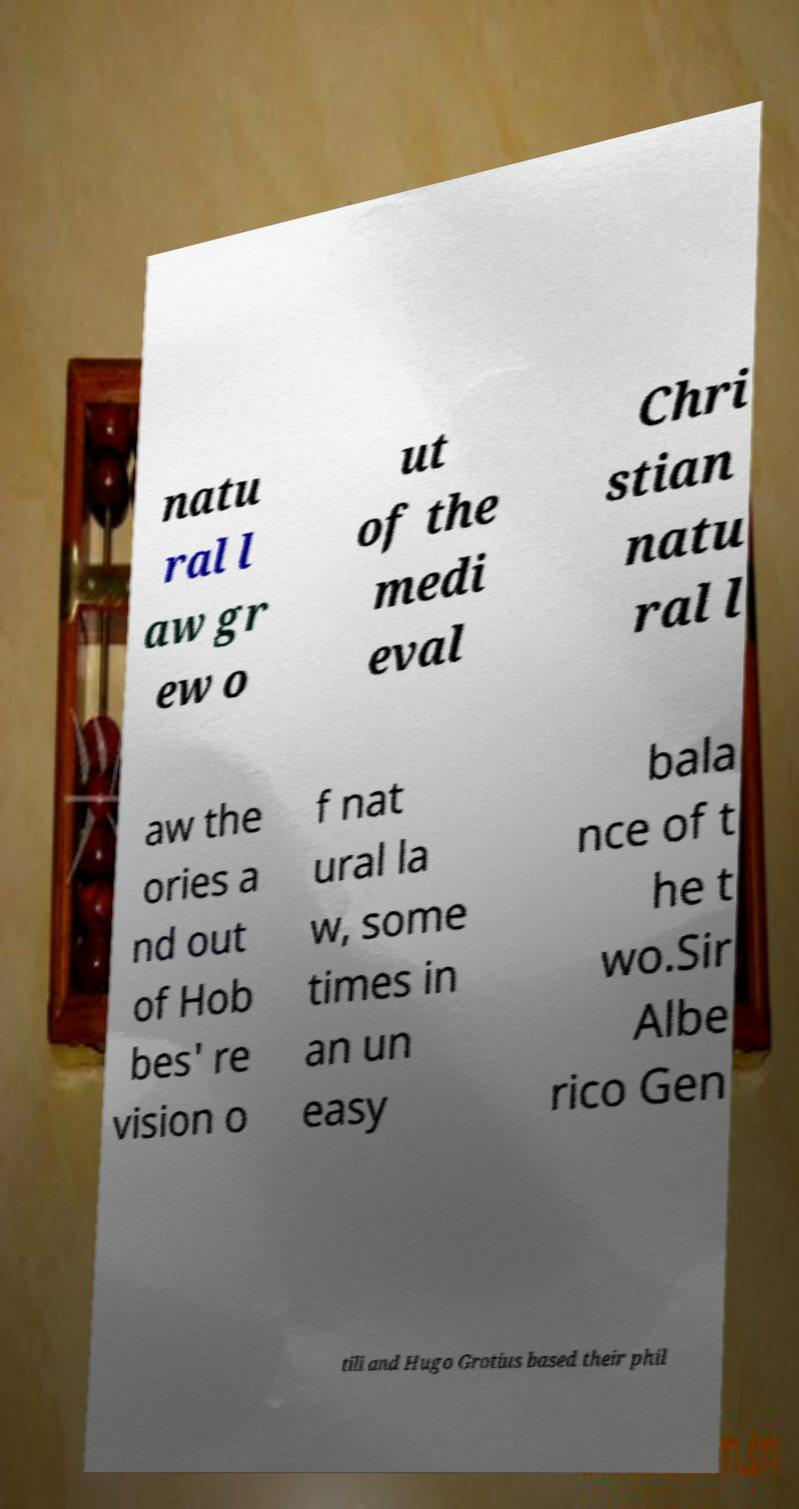Please identify and transcribe the text found in this image. natu ral l aw gr ew o ut of the medi eval Chri stian natu ral l aw the ories a nd out of Hob bes' re vision o f nat ural la w, some times in an un easy bala nce of t he t wo.Sir Albe rico Gen tili and Hugo Grotius based their phil 